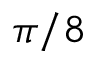Convert formula to latex. <formula><loc_0><loc_0><loc_500><loc_500>\pi / 8</formula> 